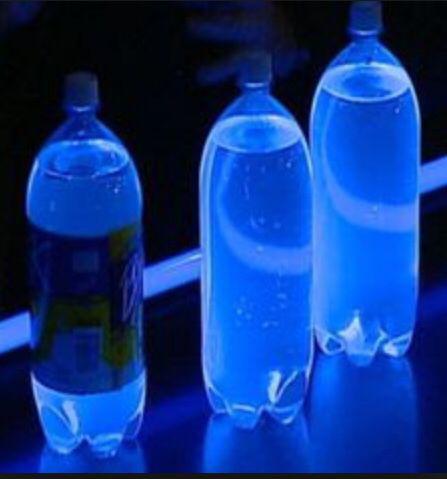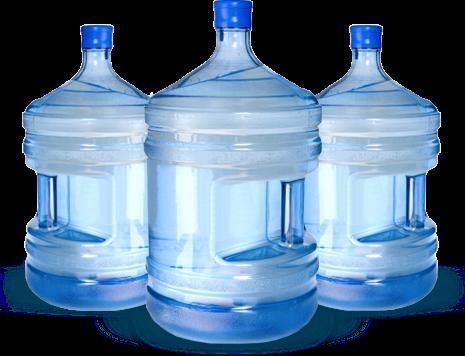The first image is the image on the left, the second image is the image on the right. Examine the images to the left and right. Is the description "There are three bottles in one of the images." accurate? Answer yes or no. Yes. 